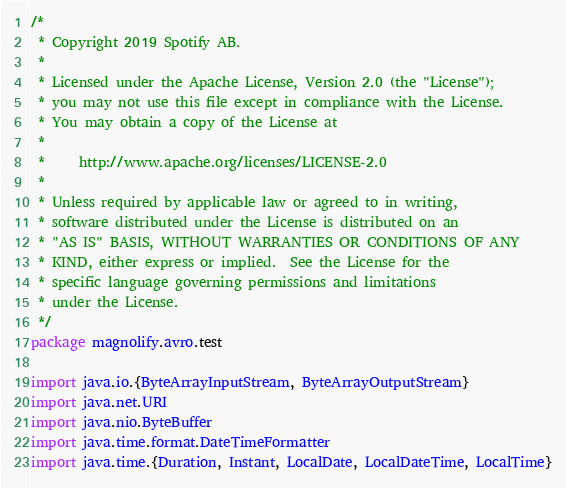<code> <loc_0><loc_0><loc_500><loc_500><_Scala_>/*
 * Copyright 2019 Spotify AB.
 *
 * Licensed under the Apache License, Version 2.0 (the "License");
 * you may not use this file except in compliance with the License.
 * You may obtain a copy of the License at
 *
 *     http://www.apache.org/licenses/LICENSE-2.0
 *
 * Unless required by applicable law or agreed to in writing,
 * software distributed under the License is distributed on an
 * "AS IS" BASIS, WITHOUT WARRANTIES OR CONDITIONS OF ANY
 * KIND, either express or implied.  See the License for the
 * specific language governing permissions and limitations
 * under the License.
 */
package magnolify.avro.test

import java.io.{ByteArrayInputStream, ByteArrayOutputStream}
import java.net.URI
import java.nio.ByteBuffer
import java.time.format.DateTimeFormatter
import java.time.{Duration, Instant, LocalDate, LocalDateTime, LocalTime}</code> 